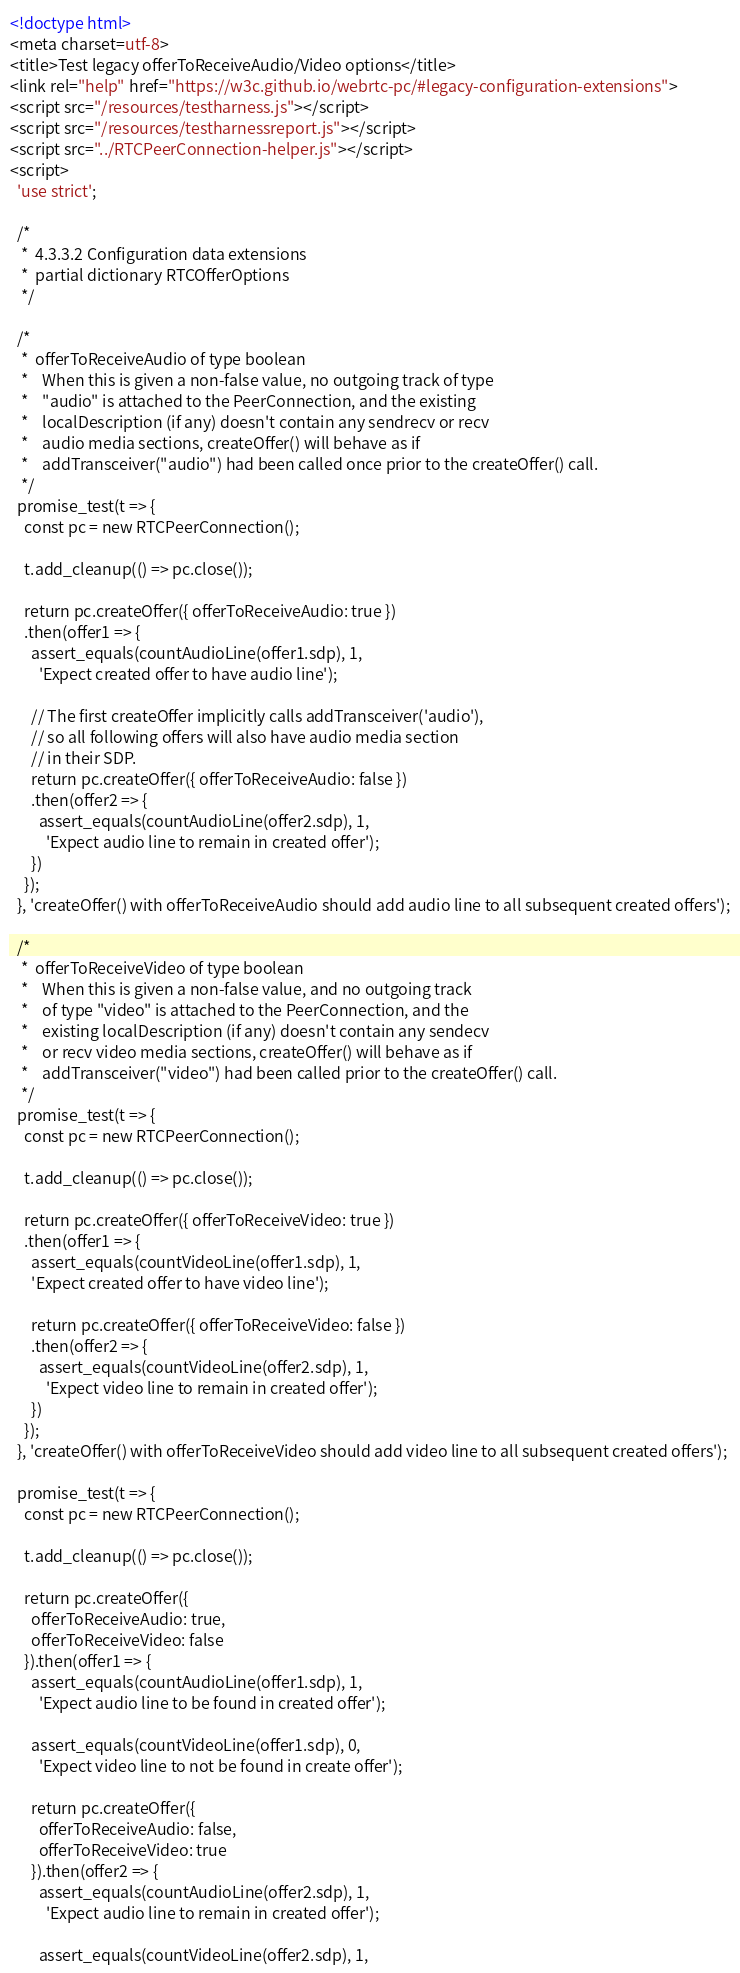<code> <loc_0><loc_0><loc_500><loc_500><_HTML_><!doctype html>
<meta charset=utf-8>
<title>Test legacy offerToReceiveAudio/Video options</title>
<link rel="help" href="https://w3c.github.io/webrtc-pc/#legacy-configuration-extensions">
<script src="/resources/testharness.js"></script>
<script src="/resources/testharnessreport.js"></script>
<script src="../RTCPeerConnection-helper.js"></script>
<script>
  'use strict';

  /*
   *  4.3.3.2 Configuration data extensions
   *  partial dictionary RTCOfferOptions
   */

  /*
   *  offerToReceiveAudio of type boolean
   *    When this is given a non-false value, no outgoing track of type
   *    "audio" is attached to the PeerConnection, and the existing
   *    localDescription (if any) doesn't contain any sendrecv or recv
   *    audio media sections, createOffer() will behave as if
   *    addTransceiver("audio") had been called once prior to the createOffer() call.
   */
  promise_test(t => {
    const pc = new RTCPeerConnection();

    t.add_cleanup(() => pc.close());

    return pc.createOffer({ offerToReceiveAudio: true })
    .then(offer1 => {
      assert_equals(countAudioLine(offer1.sdp), 1,
        'Expect created offer to have audio line');

      // The first createOffer implicitly calls addTransceiver('audio'),
      // so all following offers will also have audio media section
      // in their SDP.
      return pc.createOffer({ offerToReceiveAudio: false })
      .then(offer2 => {
        assert_equals(countAudioLine(offer2.sdp), 1,
          'Expect audio line to remain in created offer');
      })
    });
  }, 'createOffer() with offerToReceiveAudio should add audio line to all subsequent created offers');

  /*
   *  offerToReceiveVideo of type boolean
   *    When this is given a non-false value, and no outgoing track
   *    of type "video" is attached to the PeerConnection, and the
   *    existing localDescription (if any) doesn't contain any sendecv
   *    or recv video media sections, createOffer() will behave as if
   *    addTransceiver("video") had been called prior to the createOffer() call.
   */
  promise_test(t => {
    const pc = new RTCPeerConnection();

    t.add_cleanup(() => pc.close());

    return pc.createOffer({ offerToReceiveVideo: true })
    .then(offer1 => {
      assert_equals(countVideoLine(offer1.sdp), 1,
      'Expect created offer to have video line');

      return pc.createOffer({ offerToReceiveVideo: false })
      .then(offer2 => {
        assert_equals(countVideoLine(offer2.sdp), 1,
          'Expect video line to remain in created offer');
      })
    });
  }, 'createOffer() with offerToReceiveVideo should add video line to all subsequent created offers');

  promise_test(t => {
    const pc = new RTCPeerConnection();

    t.add_cleanup(() => pc.close());

    return pc.createOffer({
      offerToReceiveAudio: true,
      offerToReceiveVideo: false
    }).then(offer1 => {
      assert_equals(countAudioLine(offer1.sdp), 1,
        'Expect audio line to be found in created offer');

      assert_equals(countVideoLine(offer1.sdp), 0,
        'Expect video line to not be found in create offer');

      return pc.createOffer({
        offerToReceiveAudio: false,
        offerToReceiveVideo: true
      }).then(offer2 => {
        assert_equals(countAudioLine(offer2.sdp), 1,
          'Expect audio line to remain in created offer');

        assert_equals(countVideoLine(offer2.sdp), 1,</code> 